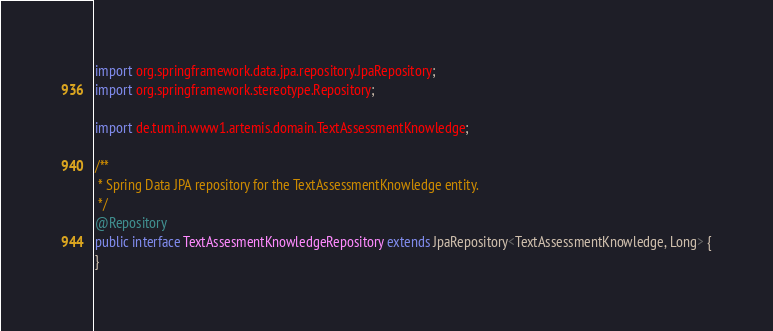<code> <loc_0><loc_0><loc_500><loc_500><_Java_>
import org.springframework.data.jpa.repository.JpaRepository;
import org.springframework.stereotype.Repository;

import de.tum.in.www1.artemis.domain.TextAssessmentKnowledge;

/**
 * Spring Data JPA repository for the TextAssessmentKnowledge entity.
 */
@Repository
public interface TextAssesmentKnowledgeRepository extends JpaRepository<TextAssessmentKnowledge, Long> {
}
</code> 